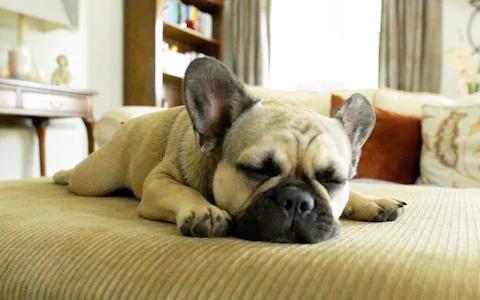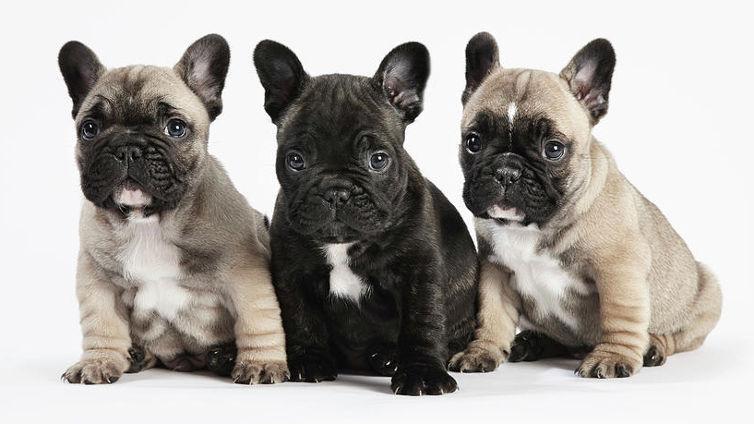The first image is the image on the left, the second image is the image on the right. Examine the images to the left and right. Is the description "The right image contains exactly three dogs." accurate? Answer yes or no. Yes. The first image is the image on the left, the second image is the image on the right. Analyze the images presented: Is the assertion "Each image contains the same number of dogs, and all dogs are posed side-by-side." valid? Answer yes or no. No. 